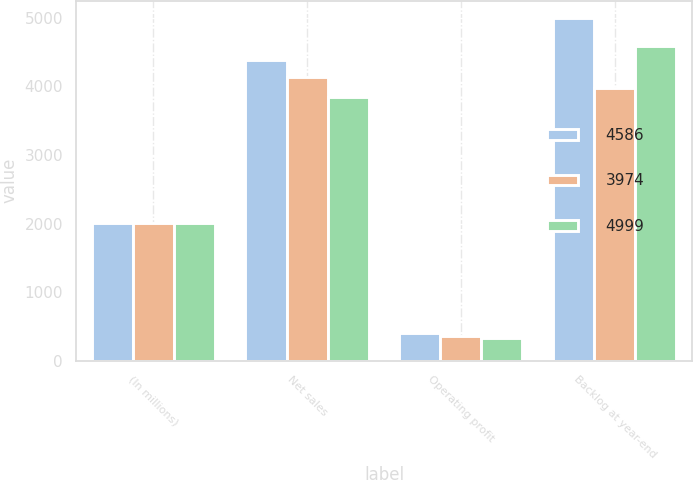Convert chart. <chart><loc_0><loc_0><loc_500><loc_500><stacked_bar_chart><ecel><fcel>(In millions)<fcel>Net sales<fcel>Operating profit<fcel>Backlog at year-end<nl><fcel>4586<fcel>2006<fcel>4387<fcel>405<fcel>4999<nl><fcel>3974<fcel>2005<fcel>4131<fcel>365<fcel>3974<nl><fcel>4999<fcel>2004<fcel>3851<fcel>334<fcel>4586<nl></chart> 